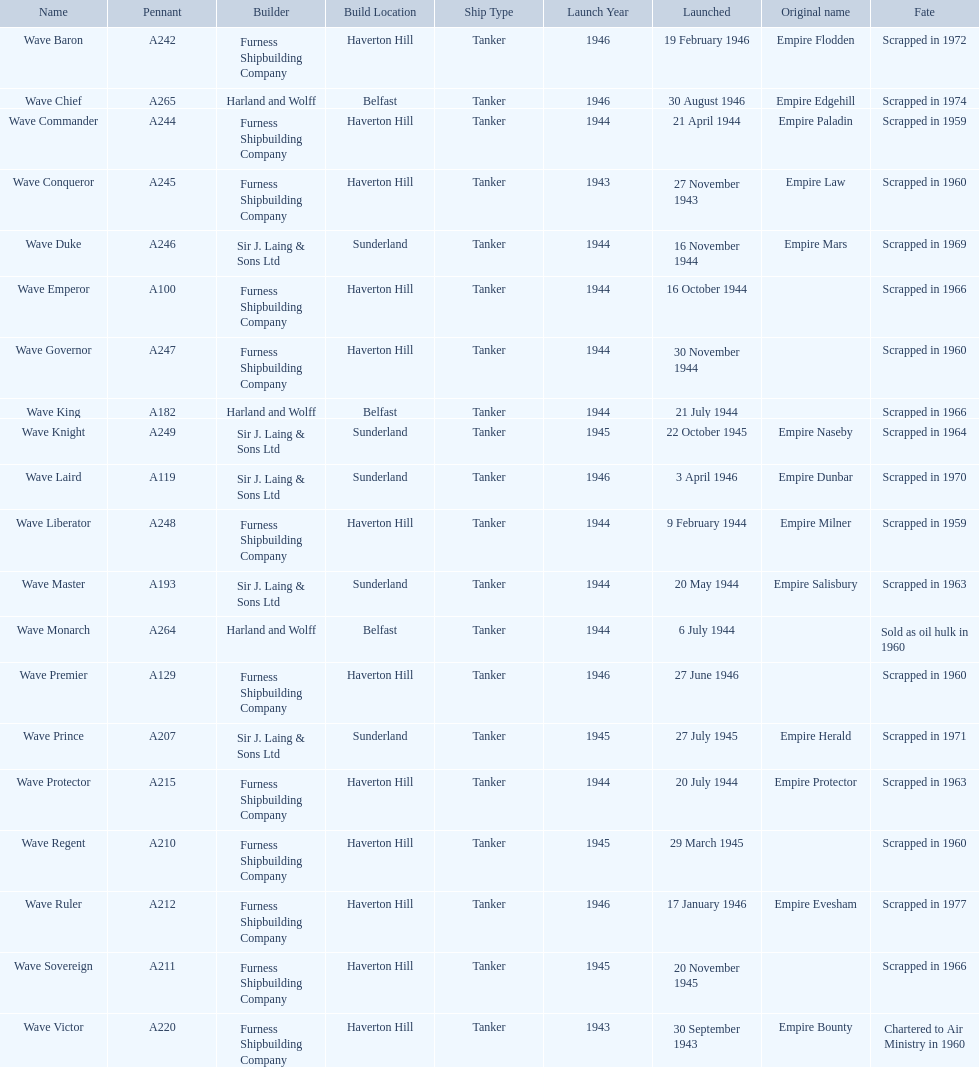Following the wave emperor, which wave-class oiler came next? Wave Duke. 